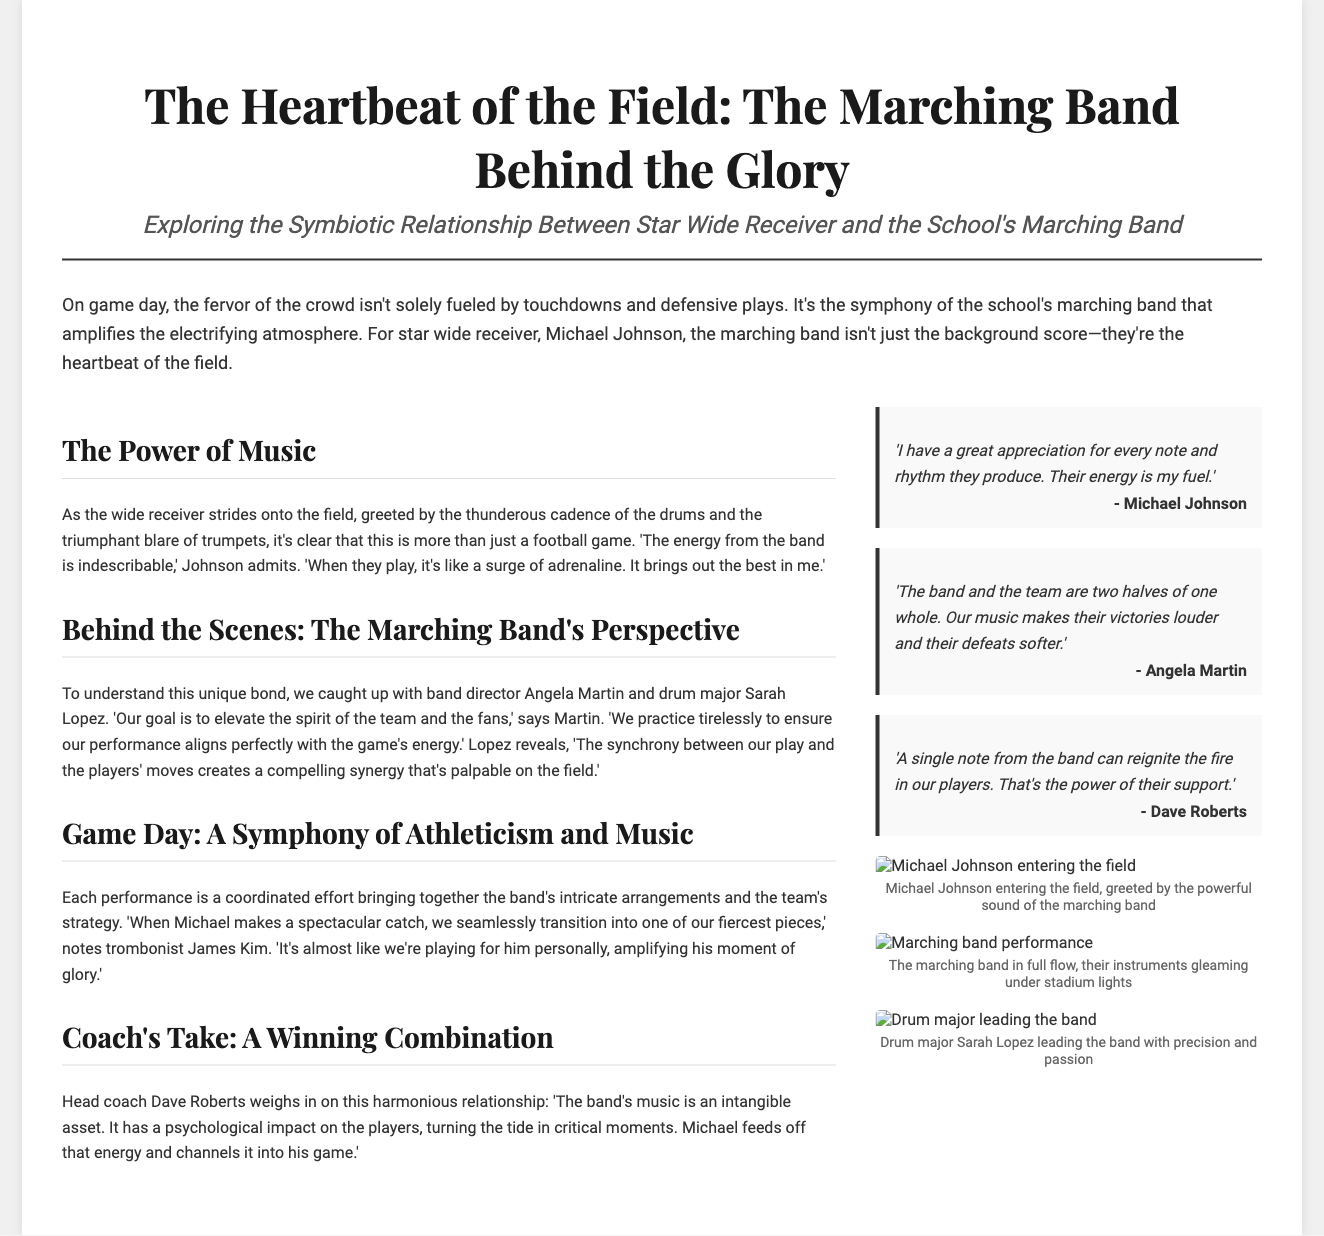What is the title of the article? The title is prominently displayed at the top of the document, detailing the focus on the marching band and the star wide receiver.
Answer: The Heartbeat of the Field: The Marching Band Behind the Glory Who is the star wide receiver mentioned in the article? The article introduces the main subject and highlights his role in relation to the marching band.
Answer: Michael Johnson What profession does Angela Martin hold? Angela Martin's role is specified in the segment discussing the band's commitment to enhancing the game atmosphere.
Answer: Band director What role does Sarah Lopez have in the marching band? Sarah Lopez's position is mentioned in the context of the band's operations and leadership.
Answer: Drum major According to Coach Dave Roberts, what is the impact of the band's music? Coach Roberts discusses the psychological influence the band's music has during games.
Answer: Psychological impact How does Michael Johnson feel about the energy from the band? His personal experience with the band's energy is clearly illustrated in his quoted statement.
Answer: Indescribable What does James Kim note happens when Michael makes a spectacular catch? The relationship between the band’s performance and the player's actions is emphasized in this part of the article.
Answer: Seamlessly transition into one of our fiercest pieces What do Angela Martin's words emphasize about the relationship between the band and the team? The quote provided by Martin characterizes the connection and synergy between the two groups.
Answer: Two halves of one whole What kind of images are included in the document? The document features imagery that complements the article and highlights the relationships discussed.
Answer: Action images of the band and Michael Johnson What key theme is explored in the article? The core focus of the article revolves around the intersection of music and sports, especially on game days.
Answer: Symbiotic relationship 